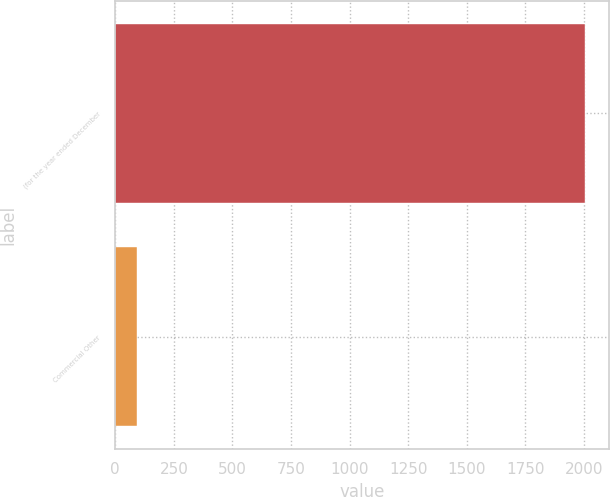Convert chart. <chart><loc_0><loc_0><loc_500><loc_500><bar_chart><fcel>(for the year ended December<fcel>Commercial Other<nl><fcel>2005<fcel>91<nl></chart> 